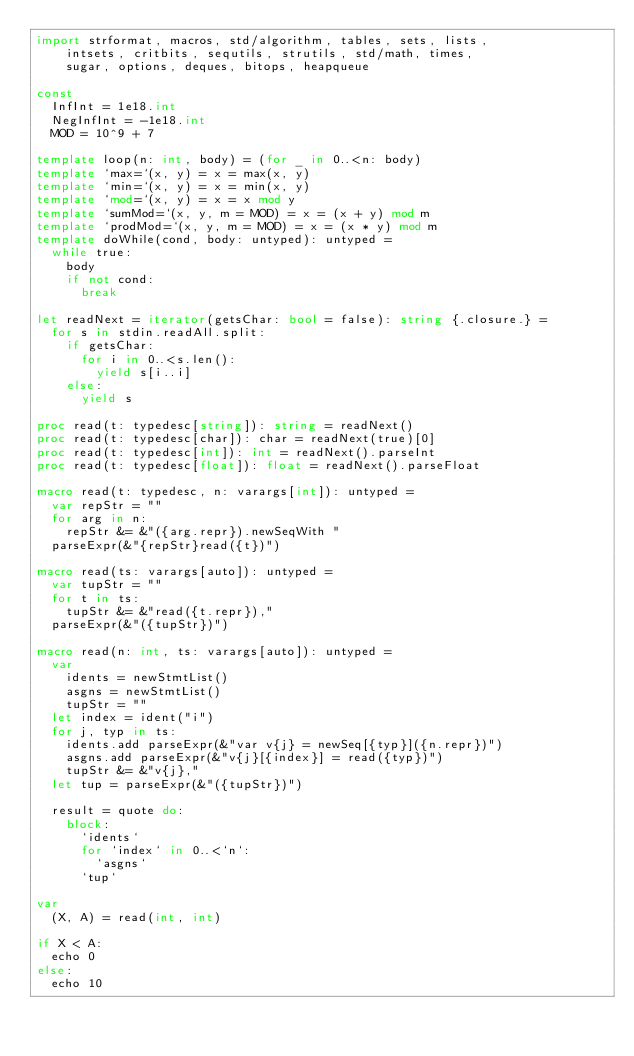Convert code to text. <code><loc_0><loc_0><loc_500><loc_500><_Nim_>import strformat, macros, std/algorithm, tables, sets, lists,
    intsets, critbits, sequtils, strutils, std/math, times,
    sugar, options, deques, bitops, heapqueue

const
  InfInt = 1e18.int
  NegInfInt = -1e18.int
  MOD = 10^9 + 7

template loop(n: int, body) = (for _ in 0..<n: body)
template `max=`(x, y) = x = max(x, y)
template `min=`(x, y) = x = min(x, y)
template `mod=`(x, y) = x = x mod y
template `sumMod=`(x, y, m = MOD) = x = (x + y) mod m
template `prodMod=`(x, y, m = MOD) = x = (x * y) mod m
template doWhile(cond, body: untyped): untyped =
  while true:
    body
    if not cond:
      break

let readNext = iterator(getsChar: bool = false): string {.closure.} =
  for s in stdin.readAll.split:
    if getsChar:
      for i in 0..<s.len():
        yield s[i..i]
    else:
      yield s

proc read(t: typedesc[string]): string = readNext()
proc read(t: typedesc[char]): char = readNext(true)[0]
proc read(t: typedesc[int]): int = readNext().parseInt
proc read(t: typedesc[float]): float = readNext().parseFloat

macro read(t: typedesc, n: varargs[int]): untyped =
  var repStr = ""
  for arg in n:
    repStr &= &"({arg.repr}).newSeqWith "
  parseExpr(&"{repStr}read({t})")

macro read(ts: varargs[auto]): untyped =
  var tupStr = ""
  for t in ts:
    tupStr &= &"read({t.repr}),"
  parseExpr(&"({tupStr})")

macro read(n: int, ts: varargs[auto]): untyped =
  var
    idents = newStmtList()
    asgns = newStmtList()
    tupStr = ""
  let index = ident("i")
  for j, typ in ts:
    idents.add parseExpr(&"var v{j} = newSeq[{typ}]({n.repr})")
    asgns.add parseExpr(&"v{j}[{index}] = read({typ})")
    tupStr &= &"v{j},"
  let tup = parseExpr(&"({tupStr})")

  result = quote do:
    block:
      `idents`
      for `index` in 0..<`n`:
        `asgns`
      `tup`

var
  (X, A) = read(int, int)

if X < A:
  echo 0
else:
  echo 10
</code> 